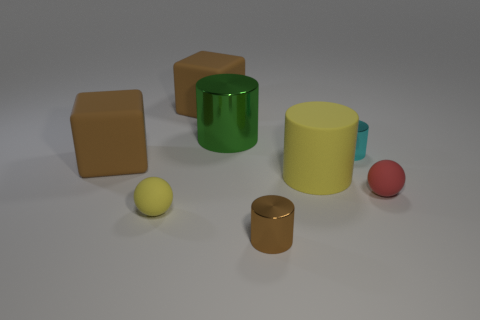Subtract all cyan cylinders. How many cylinders are left? 3 Add 1 big brown cubes. How many objects exist? 9 Subtract all purple cylinders. Subtract all yellow cubes. How many cylinders are left? 4 Subtract all balls. How many objects are left? 6 Subtract all yellow matte balls. Subtract all big green shiny cylinders. How many objects are left? 6 Add 6 brown cylinders. How many brown cylinders are left? 7 Add 6 green cylinders. How many green cylinders exist? 7 Subtract 1 cyan cylinders. How many objects are left? 7 